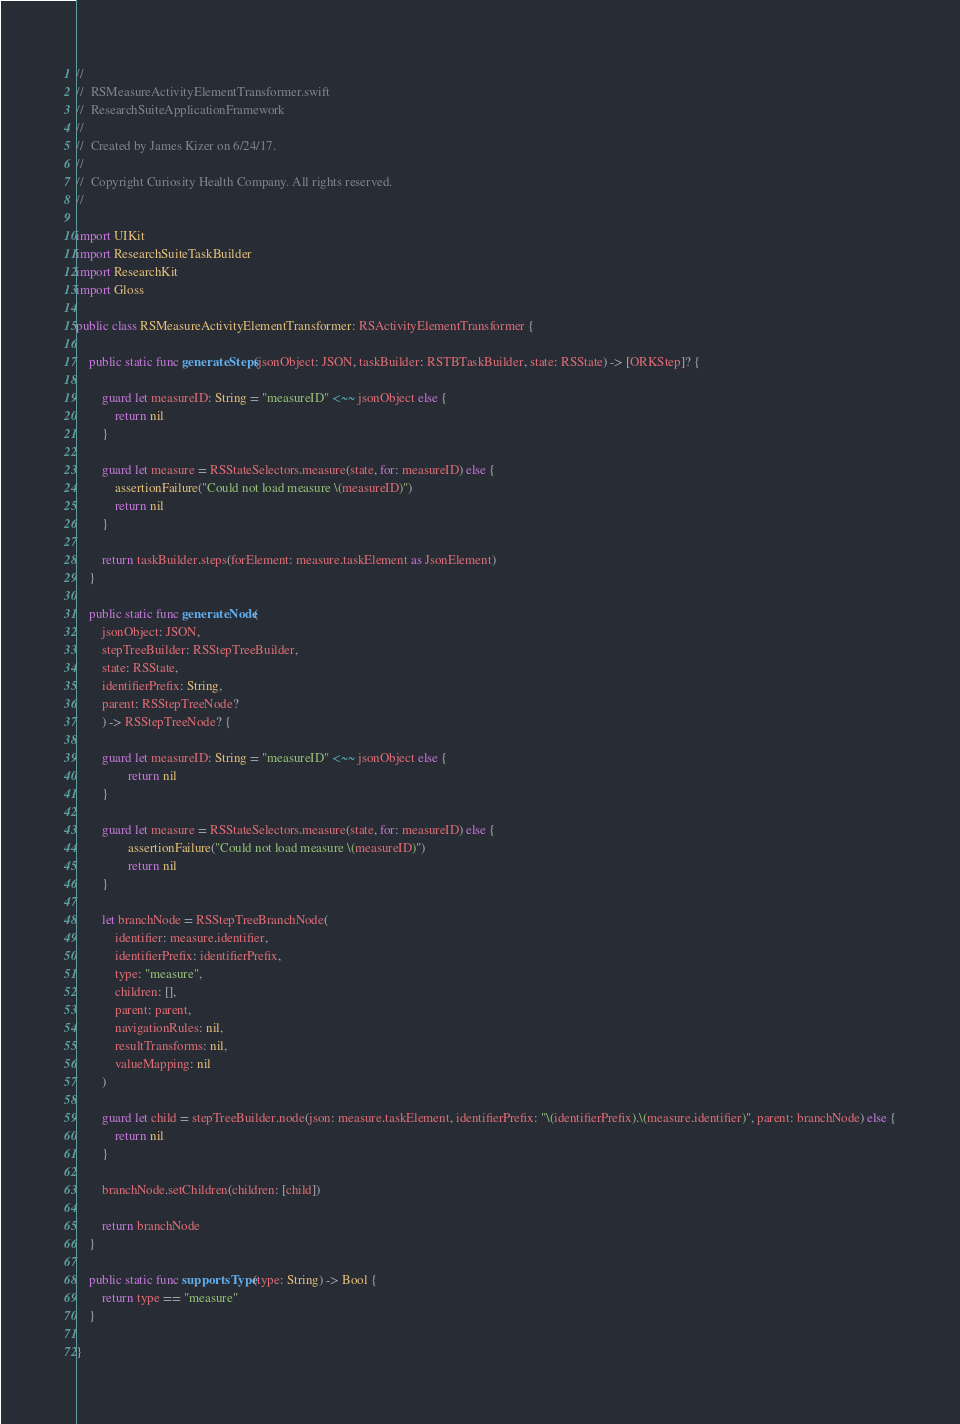<code> <loc_0><loc_0><loc_500><loc_500><_Swift_>//
//  RSMeasureActivityElementTransformer.swift
//  ResearchSuiteApplicationFramework
//
//  Created by James Kizer on 6/24/17.
//
//  Copyright Curiosity Health Company. All rights reserved.
//

import UIKit
import ResearchSuiteTaskBuilder
import ResearchKit
import Gloss

public class RSMeasureActivityElementTransformer: RSActivityElementTransformer {
    
    public static func generateSteps(jsonObject: JSON, taskBuilder: RSTBTaskBuilder, state: RSState) -> [ORKStep]? {
        
        guard let measureID: String = "measureID" <~~ jsonObject else {
            return nil
        }
        
        guard let measure = RSStateSelectors.measure(state, for: measureID) else {
            assertionFailure("Could not load measure \(measureID)")
            return nil
        }
        
        return taskBuilder.steps(forElement: measure.taskElement as JsonElement)
    }
    
    public static func generateNode(
        jsonObject: JSON,
        stepTreeBuilder: RSStepTreeBuilder,
        state: RSState,
        identifierPrefix: String,
        parent: RSStepTreeNode?
        ) -> RSStepTreeNode? {
        
        guard let measureID: String = "measureID" <~~ jsonObject else {
                return nil
        }
        
        guard let measure = RSStateSelectors.measure(state, for: measureID) else {
                assertionFailure("Could not load measure \(measureID)")
                return nil
        }
        
        let branchNode = RSStepTreeBranchNode(
            identifier: measure.identifier,
            identifierPrefix: identifierPrefix,
            type: "measure",
            children: [],
            parent: parent,
            navigationRules: nil,
            resultTransforms: nil,
            valueMapping: nil
        )
        
        guard let child = stepTreeBuilder.node(json: measure.taskElement, identifierPrefix: "\(identifierPrefix).\(measure.identifier)", parent: branchNode) else {
            return nil
        }
        
        branchNode.setChildren(children: [child])
        
        return branchNode
    }
    
    public static func supportsType(type: String) -> Bool {
        return type == "measure"
    }

}
</code> 